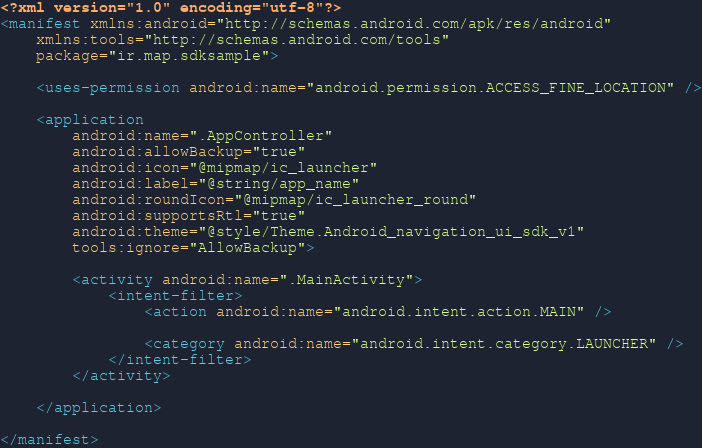<code> <loc_0><loc_0><loc_500><loc_500><_XML_><?xml version="1.0" encoding="utf-8"?>
<manifest xmlns:android="http://schemas.android.com/apk/res/android"
    xmlns:tools="http://schemas.android.com/tools"
    package="ir.map.sdksample">

    <uses-permission android:name="android.permission.ACCESS_FINE_LOCATION" />

    <application
        android:name=".AppController"
        android:allowBackup="true"
        android:icon="@mipmap/ic_launcher"
        android:label="@string/app_name"
        android:roundIcon="@mipmap/ic_launcher_round"
        android:supportsRtl="true"
        android:theme="@style/Theme.Android_navigation_ui_sdk_v1"
        tools:ignore="AllowBackup">

        <activity android:name=".MainActivity">
            <intent-filter>
                <action android:name="android.intent.action.MAIN" />

                <category android:name="android.intent.category.LAUNCHER" />
            </intent-filter>
        </activity>

    </application>

</manifest></code> 